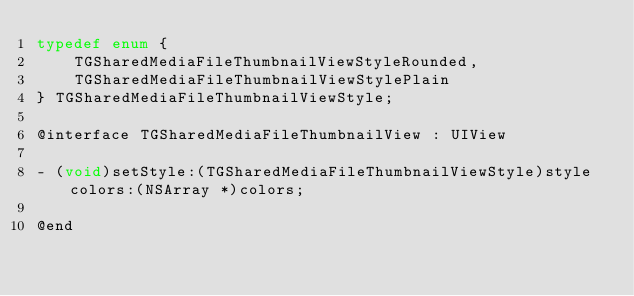<code> <loc_0><loc_0><loc_500><loc_500><_C_>typedef enum {
    TGSharedMediaFileThumbnailViewStyleRounded,
    TGSharedMediaFileThumbnailViewStylePlain
} TGSharedMediaFileThumbnailViewStyle;

@interface TGSharedMediaFileThumbnailView : UIView

- (void)setStyle:(TGSharedMediaFileThumbnailViewStyle)style colors:(NSArray *)colors;

@end
</code> 